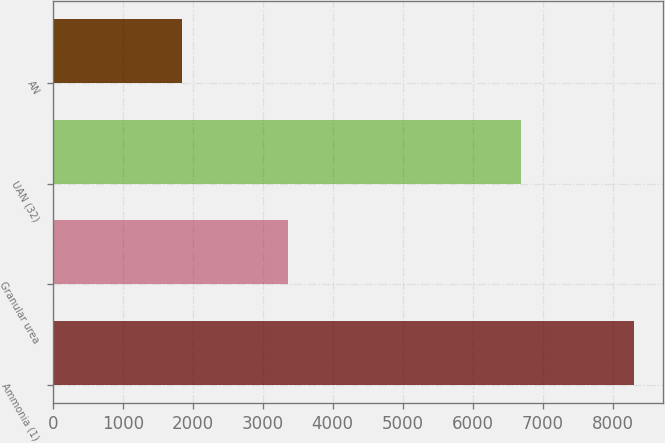Convert chart. <chart><loc_0><loc_0><loc_500><loc_500><bar_chart><fcel>Ammonia (1)<fcel>Granular urea<fcel>UAN (32)<fcel>AN<nl><fcel>8307<fcel>3368<fcel>6698<fcel>1845<nl></chart> 